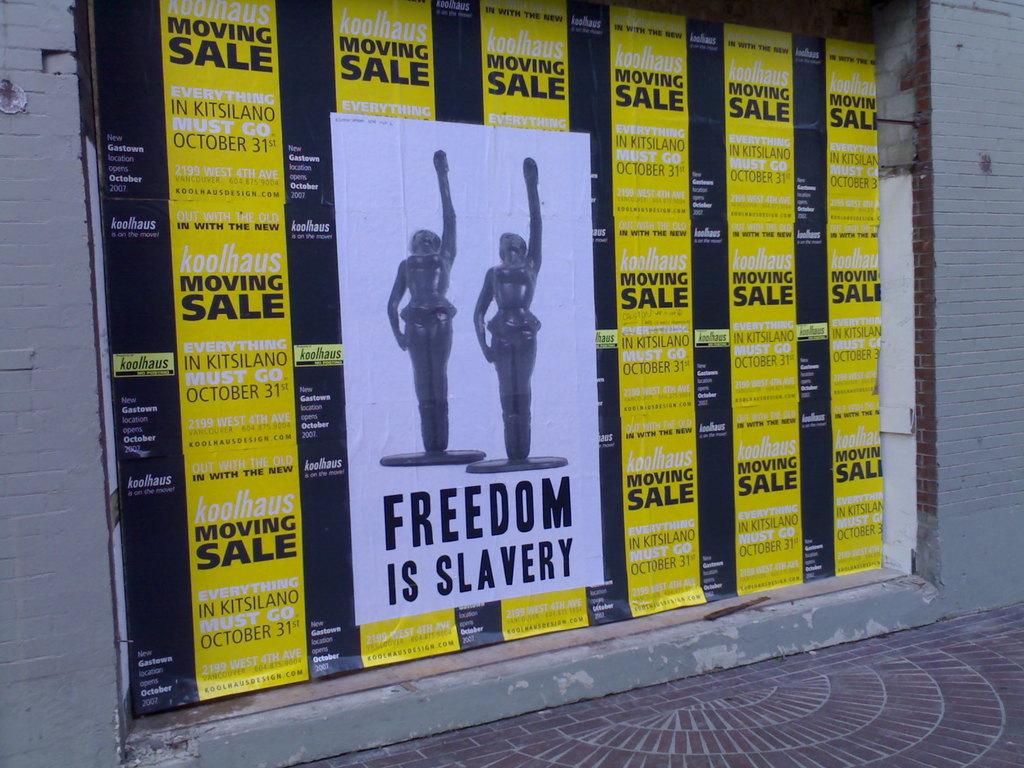What's the white poster say?
Offer a very short reply. Freedom is slavery. 